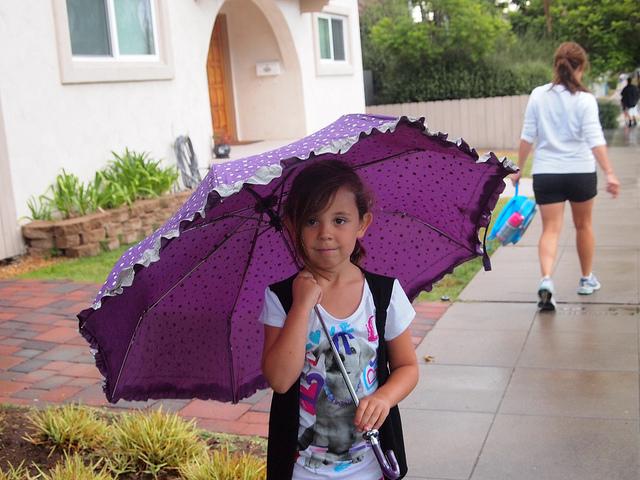What color is her umbrella?
Keep it brief. Purple. What color is the child's hair?
Quick response, please. Brown. What color is the umbrella?
Keep it brief. Purple. What is keeping her hair from her face?
Give a very brief answer. Ponytail. Is the girl happy?
Short answer required. Yes. How is the ground?
Write a very short answer. Wet. Is this umbrella not a bit too big for this child?
Keep it brief. No. 